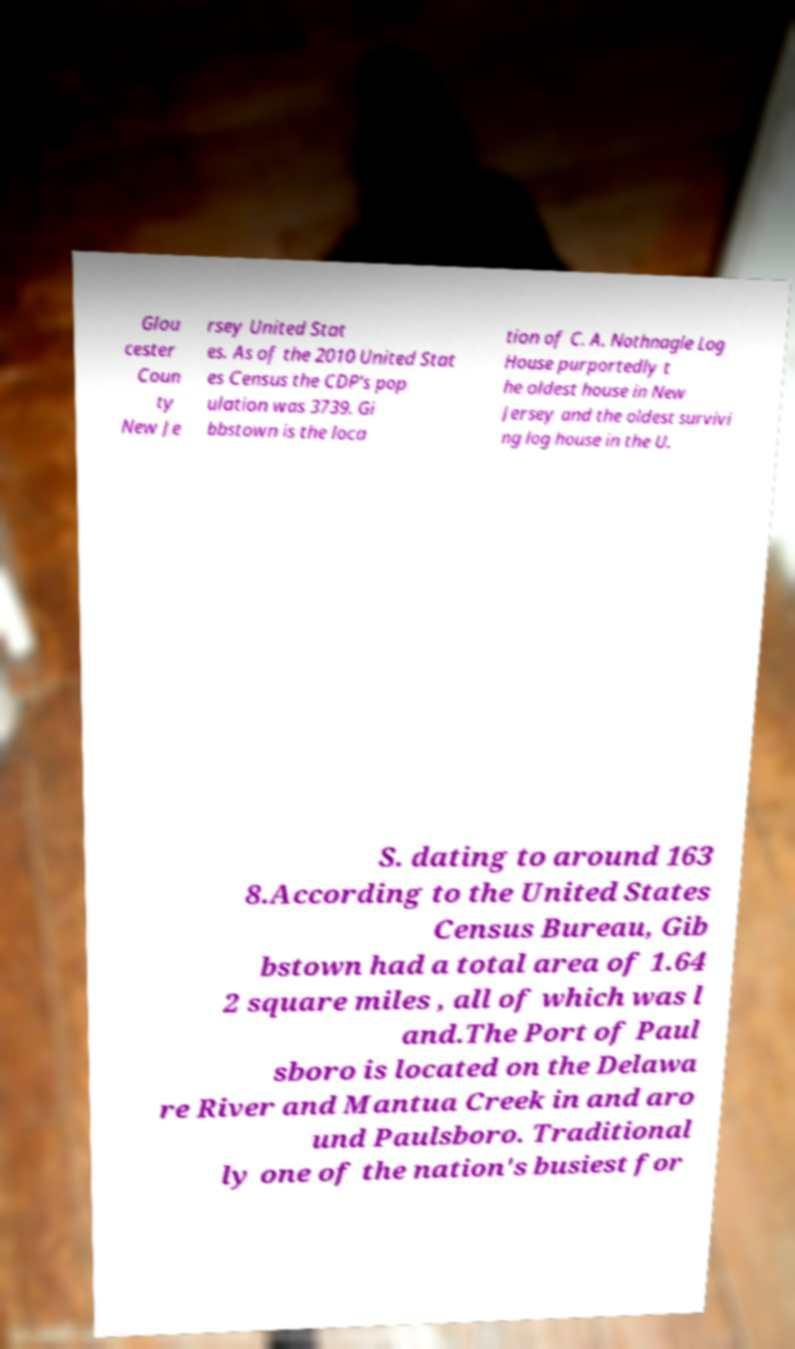There's text embedded in this image that I need extracted. Can you transcribe it verbatim? Glou cester Coun ty New Je rsey United Stat es. As of the 2010 United Stat es Census the CDP's pop ulation was 3739. Gi bbstown is the loca tion of C. A. Nothnagle Log House purportedly t he oldest house in New Jersey and the oldest survivi ng log house in the U. S. dating to around 163 8.According to the United States Census Bureau, Gib bstown had a total area of 1.64 2 square miles , all of which was l and.The Port of Paul sboro is located on the Delawa re River and Mantua Creek in and aro und Paulsboro. Traditional ly one of the nation's busiest for 